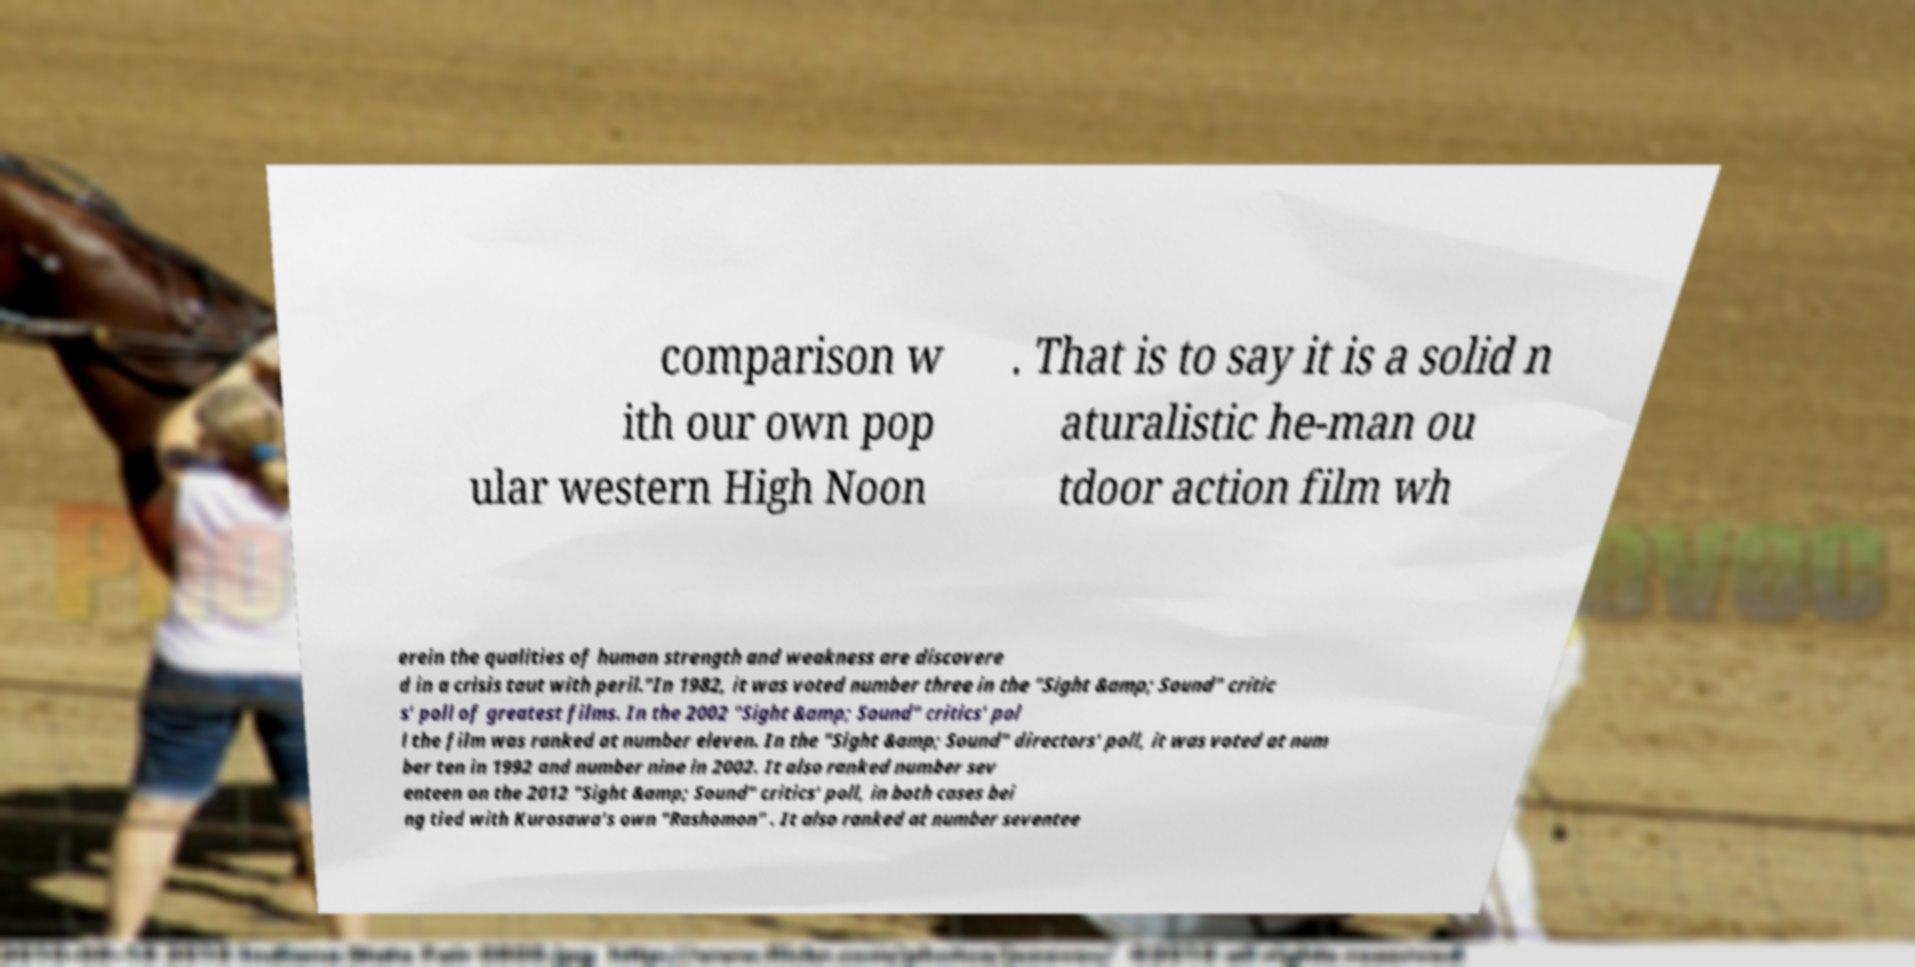Please read and relay the text visible in this image. What does it say? comparison w ith our own pop ular western High Noon . That is to say it is a solid n aturalistic he-man ou tdoor action film wh erein the qualities of human strength and weakness are discovere d in a crisis taut with peril."In 1982, it was voted number three in the "Sight &amp; Sound" critic s' poll of greatest films. In the 2002 "Sight &amp; Sound" critics' pol l the film was ranked at number eleven. In the "Sight &amp; Sound" directors' poll, it was voted at num ber ten in 1992 and number nine in 2002. It also ranked number sev enteen on the 2012 "Sight &amp; Sound" critics' poll, in both cases bei ng tied with Kurosawa's own "Rashomon" . It also ranked at number seventee 